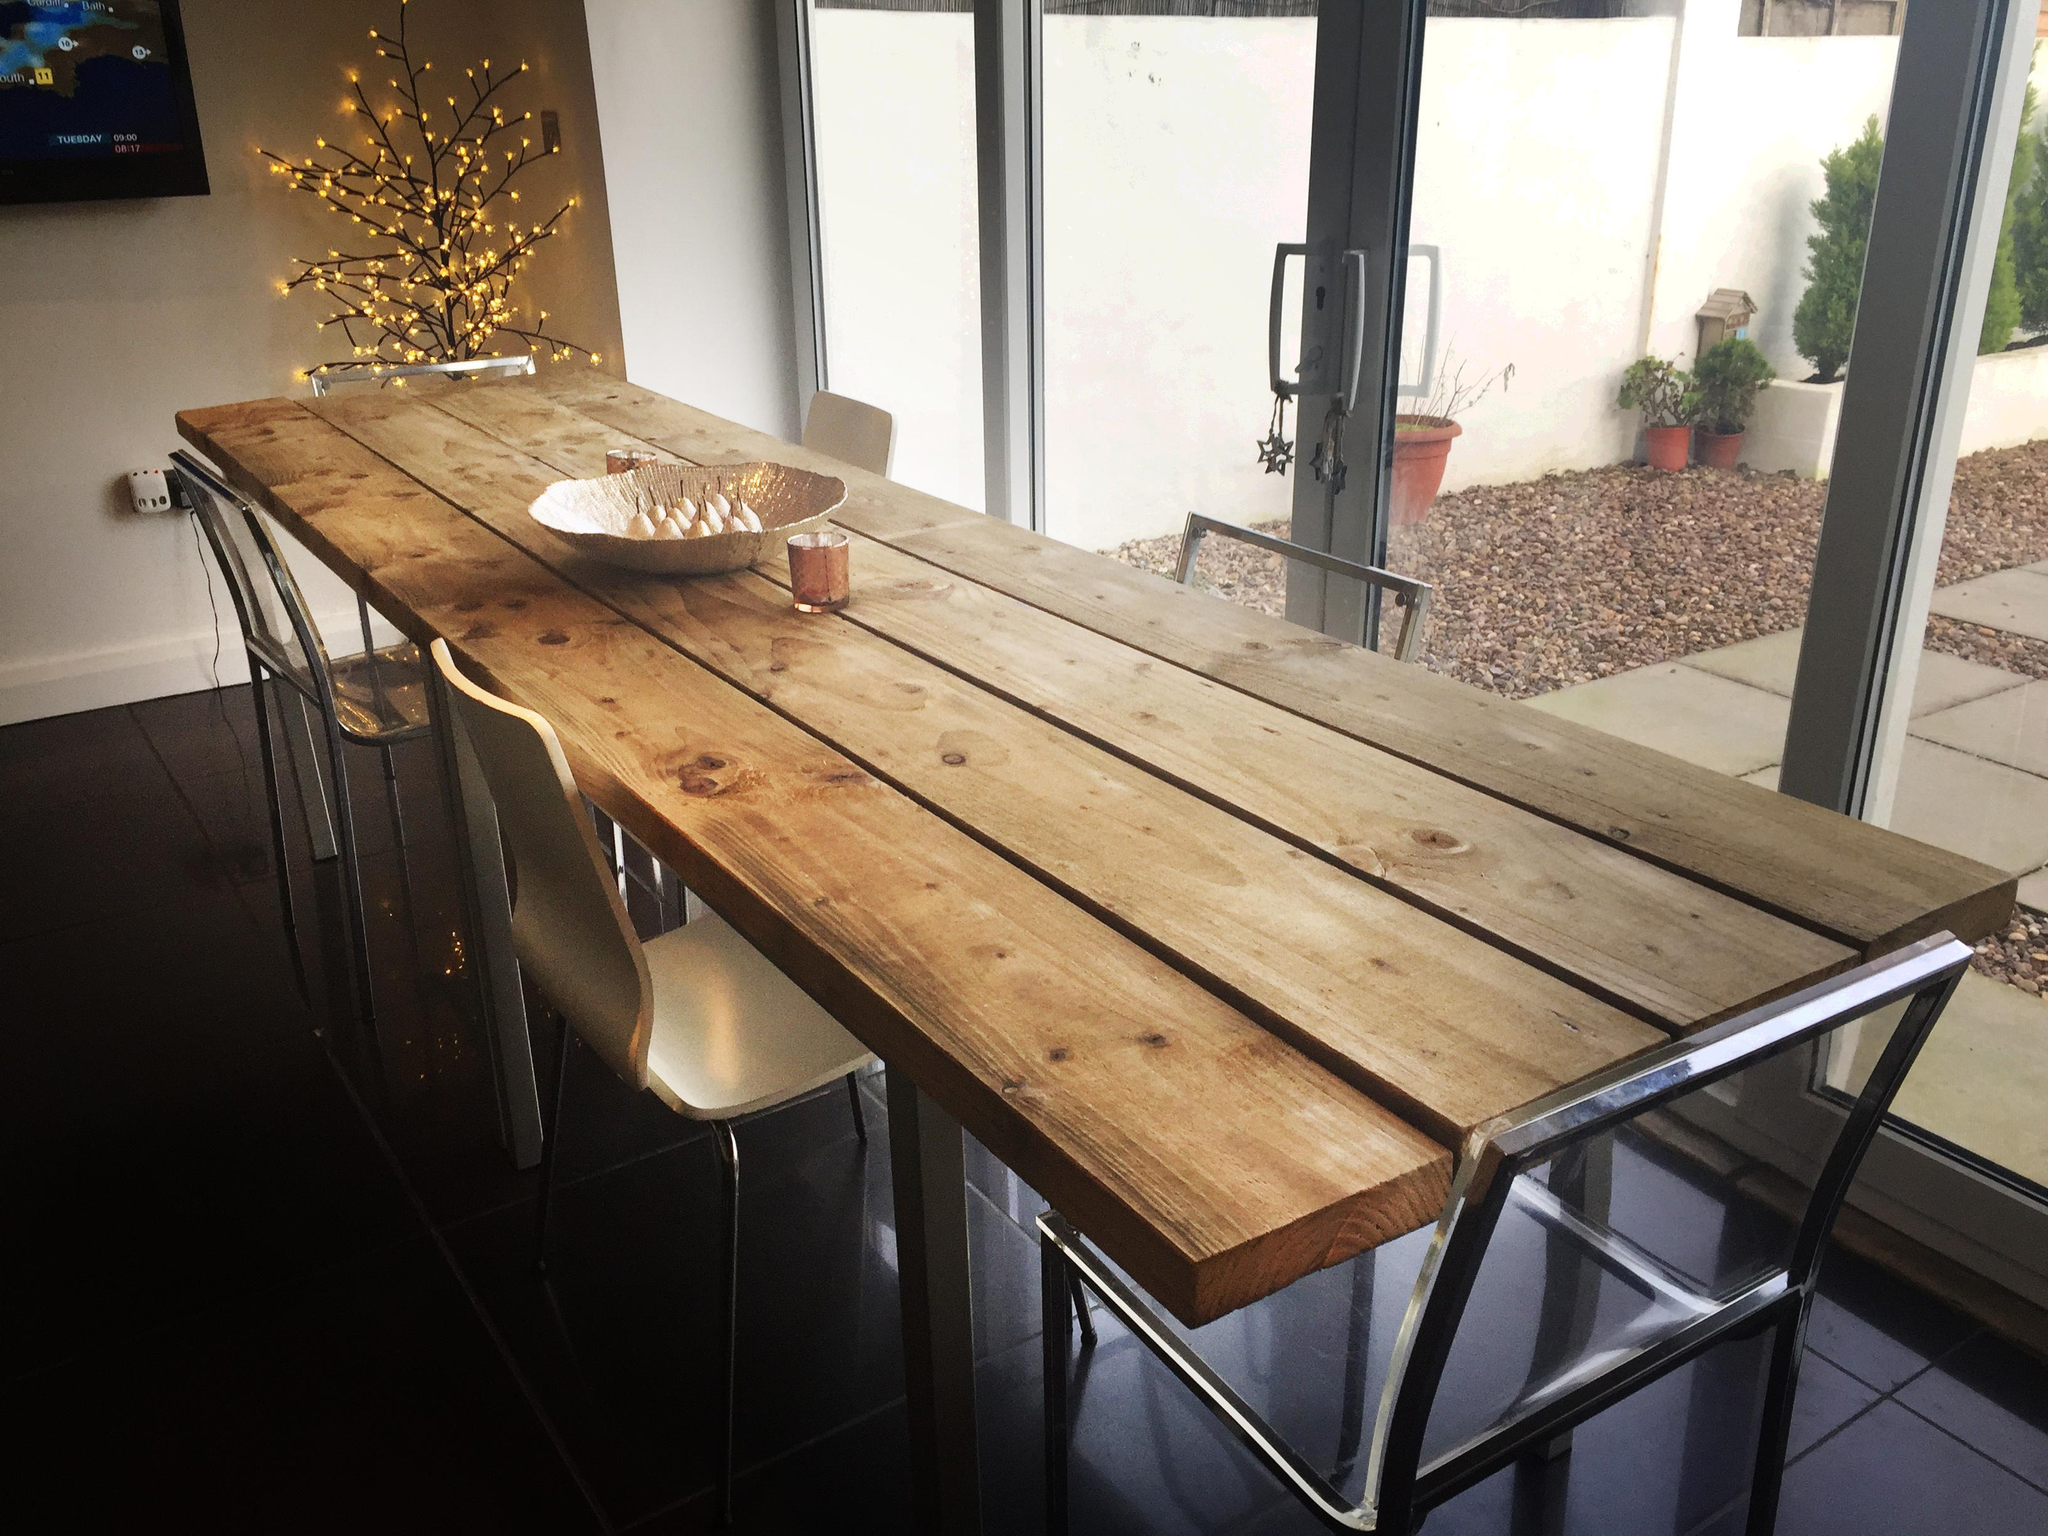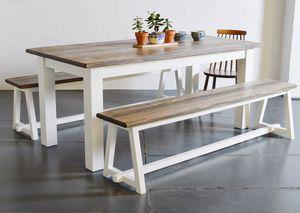The first image is the image on the left, the second image is the image on the right. Given the left and right images, does the statement "There are at least two frames on the wall." hold true? Answer yes or no. No. 